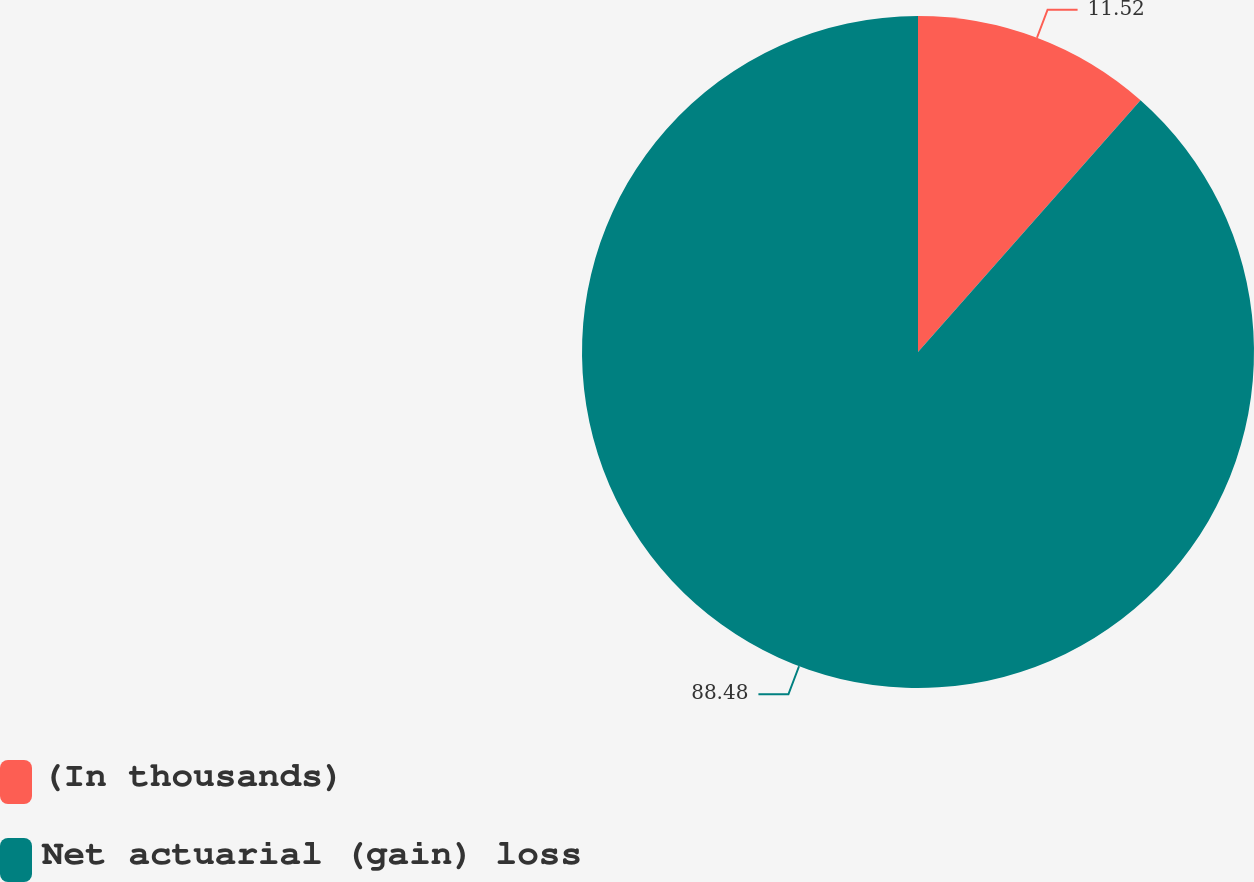Convert chart to OTSL. <chart><loc_0><loc_0><loc_500><loc_500><pie_chart><fcel>(In thousands)<fcel>Net actuarial (gain) loss<nl><fcel>11.52%<fcel>88.48%<nl></chart> 